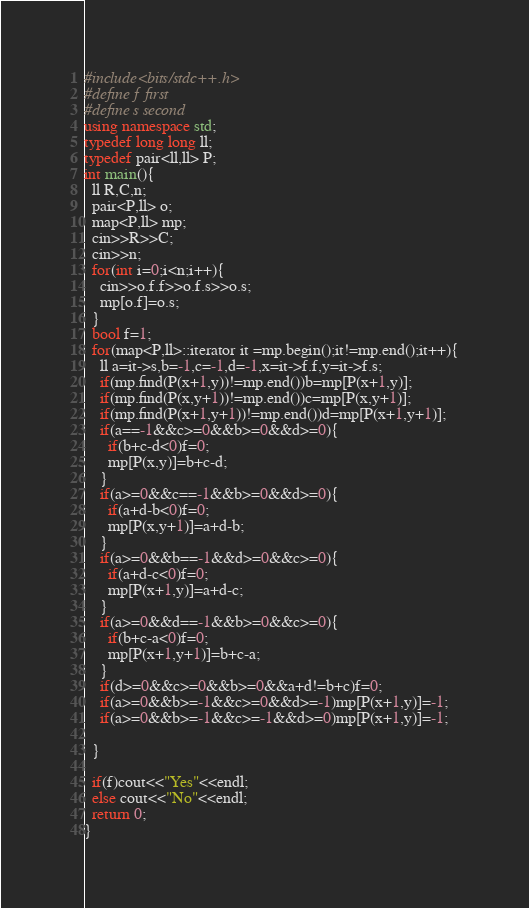Convert code to text. <code><loc_0><loc_0><loc_500><loc_500><_C++_>#include<bits/stdc++.h>
#define f first 
#define s second 
using namespace std;
typedef long long ll;
typedef pair<ll,ll> P;
int main(){
  ll R,C,n;
  pair<P,ll> o;
  map<P,ll> mp;
  cin>>R>>C;
  cin>>n;
  for(int i=0;i<n;i++){
    cin>>o.f.f>>o.f.s>>o.s;
    mp[o.f]=o.s;
  }
  bool f=1;
  for(map<P,ll>::iterator it =mp.begin();it!=mp.end();it++){
    ll a=it->s,b=-1,c=-1,d=-1,x=it->f.f,y=it->f.s;
    if(mp.find(P(x+1,y))!=mp.end())b=mp[P(x+1,y)];
    if(mp.find(P(x,y+1))!=mp.end())c=mp[P(x,y+1)];
    if(mp.find(P(x+1,y+1))!=mp.end())d=mp[P(x+1,y+1)];
    if(a==-1&&c>=0&&b>=0&&d>=0){
      if(b+c-d<0)f=0;
      mp[P(x,y)]=b+c-d;
    }
    if(a>=0&&c==-1&&b>=0&&d>=0){
      if(a+d-b<0)f=0;
      mp[P(x,y+1)]=a+d-b;
    }
    if(a>=0&&b==-1&&d>=0&&c>=0){
      if(a+d-c<0)f=0;
      mp[P(x+1,y)]=a+d-c;
    }
    if(a>=0&&d==-1&&b>=0&&c>=0){
      if(b+c-a<0)f=0;
      mp[P(x+1,y+1)]=b+c-a;
    }
    if(d>=0&&c>=0&&b>=0&&a+d!=b+c)f=0;
    if(a>=0&&b>=-1&&c>=0&&d>=-1)mp[P(x+1,y)]=-1;
    if(a>=0&&b>=-1&&c>=-1&&d>=0)mp[P(x+1,y)]=-1;

  }

  if(f)cout<<"Yes"<<endl;
  else cout<<"No"<<endl;
  return 0;
}
</code> 